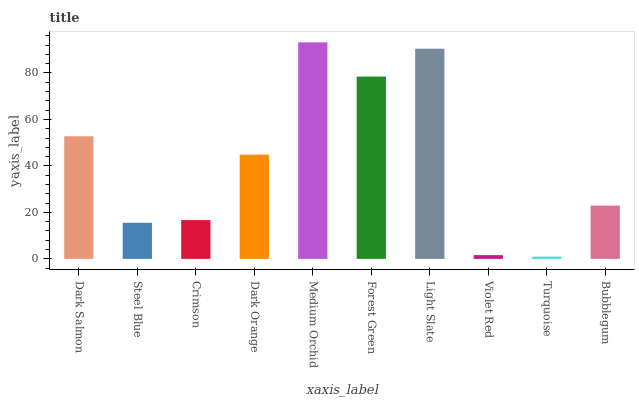Is Turquoise the minimum?
Answer yes or no. Yes. Is Medium Orchid the maximum?
Answer yes or no. Yes. Is Steel Blue the minimum?
Answer yes or no. No. Is Steel Blue the maximum?
Answer yes or no. No. Is Dark Salmon greater than Steel Blue?
Answer yes or no. Yes. Is Steel Blue less than Dark Salmon?
Answer yes or no. Yes. Is Steel Blue greater than Dark Salmon?
Answer yes or no. No. Is Dark Salmon less than Steel Blue?
Answer yes or no. No. Is Dark Orange the high median?
Answer yes or no. Yes. Is Bubblegum the low median?
Answer yes or no. Yes. Is Turquoise the high median?
Answer yes or no. No. Is Steel Blue the low median?
Answer yes or no. No. 